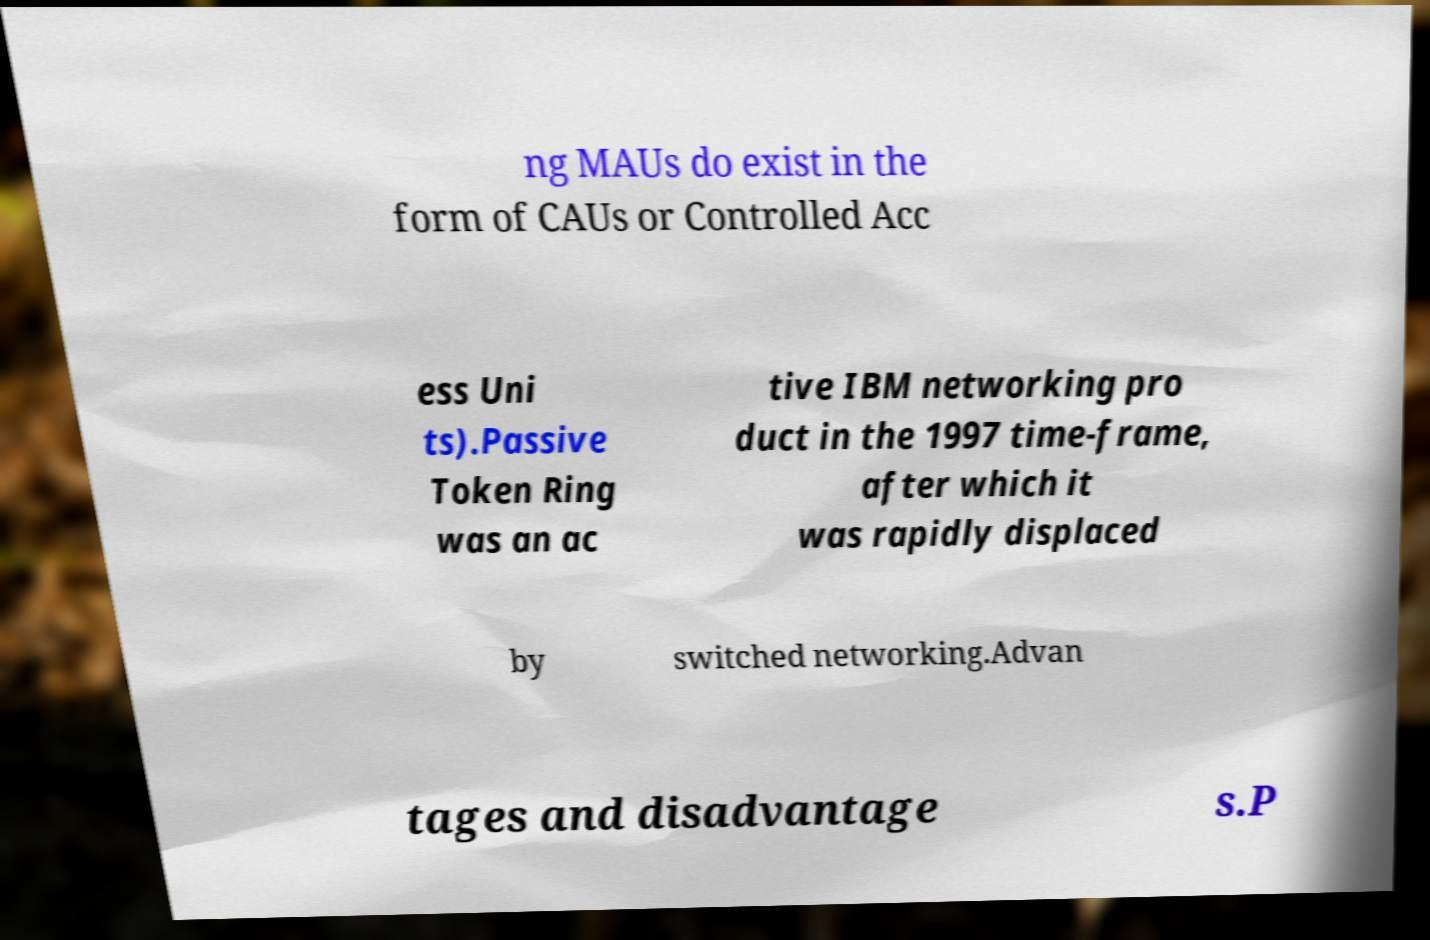Could you assist in decoding the text presented in this image and type it out clearly? ng MAUs do exist in the form of CAUs or Controlled Acc ess Uni ts).Passive Token Ring was an ac tive IBM networking pro duct in the 1997 time-frame, after which it was rapidly displaced by switched networking.Advan tages and disadvantage s.P 